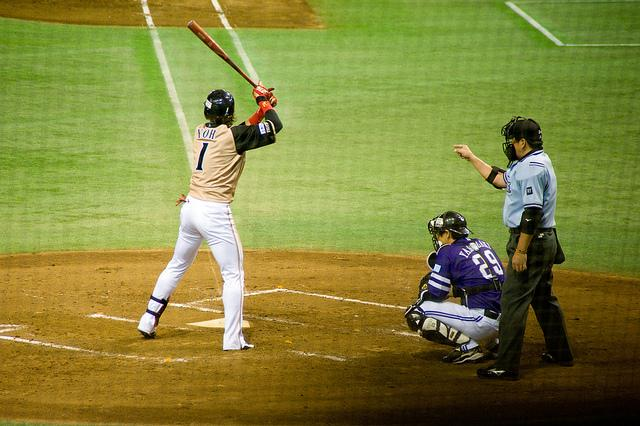Why is the guy in purple crouching?

Choices:
A) referee
B) injured
C) catcher's stance
D) fielding ball catcher's stance 